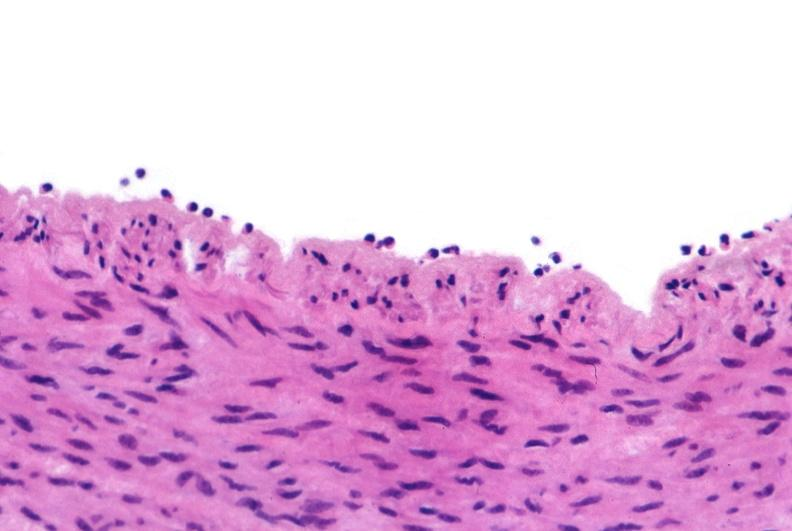s leiomyosarcoma present?
Answer the question using a single word or phrase. No 